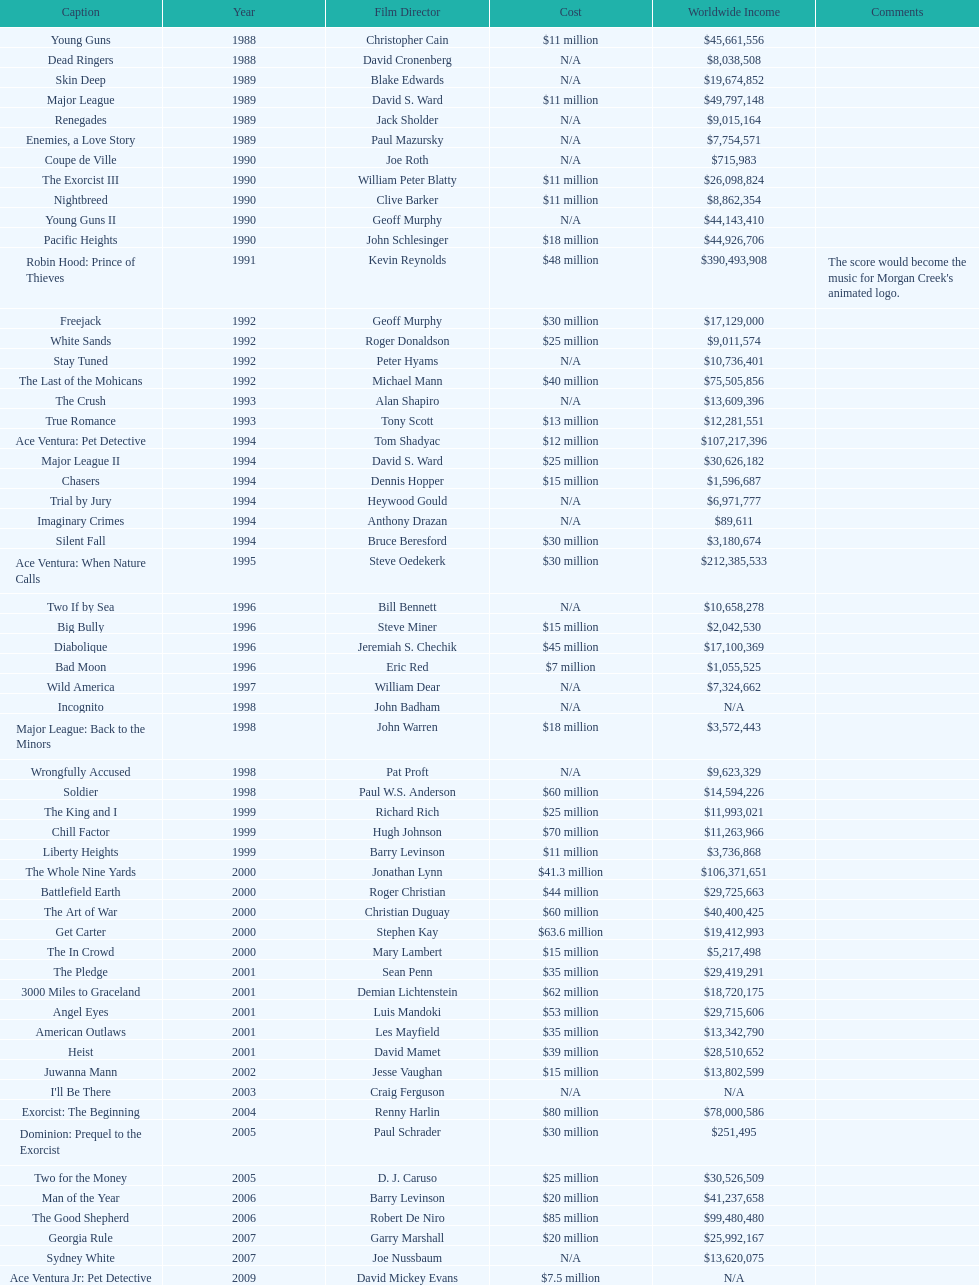Which morgan creek film grossed the most worldwide? Robin Hood: Prince of Thieves. 